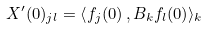Convert formula to latex. <formula><loc_0><loc_0><loc_500><loc_500>X ^ { \prime } ( 0 ) _ { j l } = { \langle } f _ { j } ( 0 ) \, , B _ { k } f _ { l } ( 0 ) \rangle _ { k }</formula> 